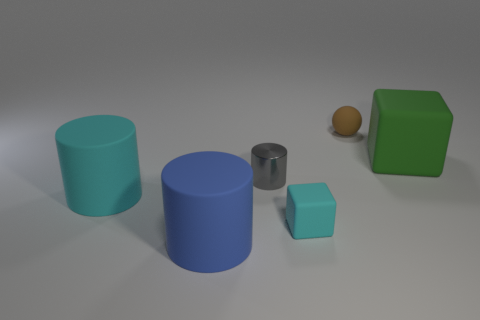What number of big green matte things are in front of the tiny rubber object that is in front of the tiny rubber object behind the large green object? In the scene, there is one large green cube and no big green objects in front of the tiny rubber object positioned in front of another tiny rubber object, which itself is behind the large green cube. Therefore, the number of big green matte things in front of the specified tiny rubber object is zero. 